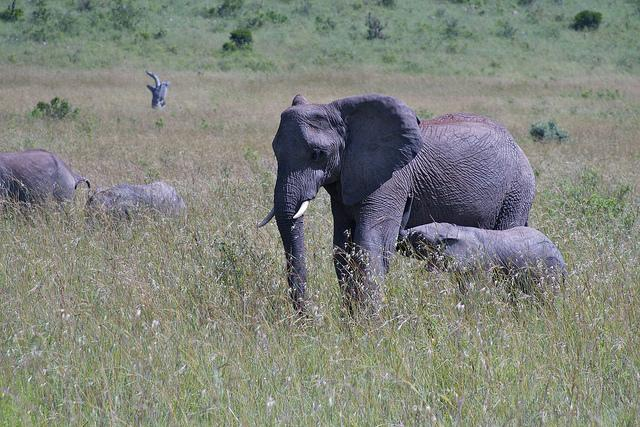What is the sharpest item here? Please explain your reasoning. tusks. The white items on their faces are sharp. 